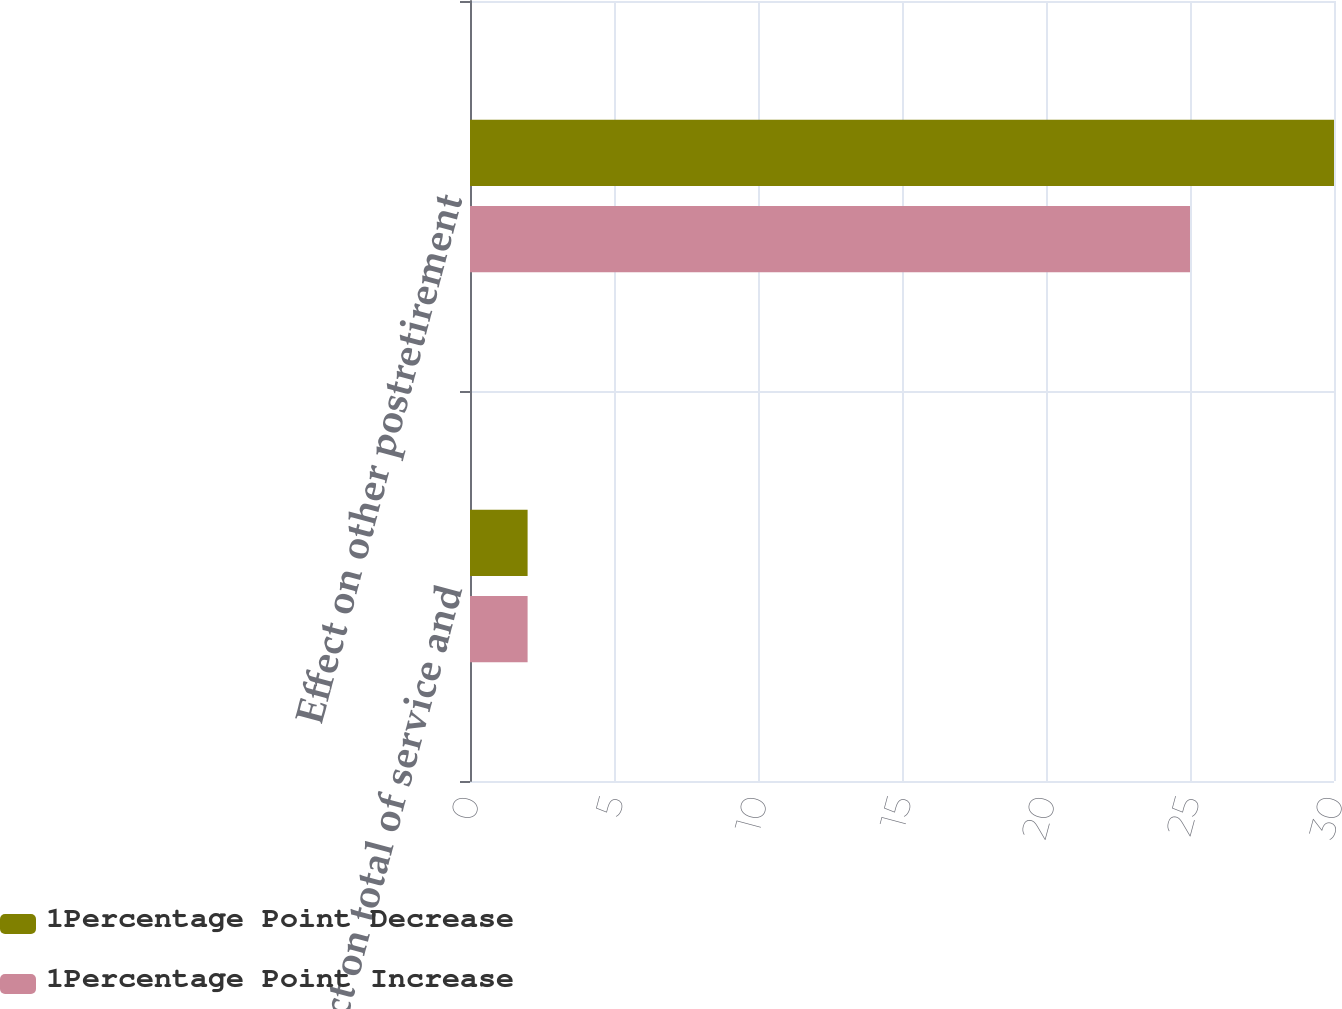Convert chart to OTSL. <chart><loc_0><loc_0><loc_500><loc_500><stacked_bar_chart><ecel><fcel>Effect on total of service and<fcel>Effect on other postretirement<nl><fcel>1Percentage Point Decrease<fcel>2<fcel>30<nl><fcel>1Percentage Point Increase<fcel>2<fcel>25<nl></chart> 